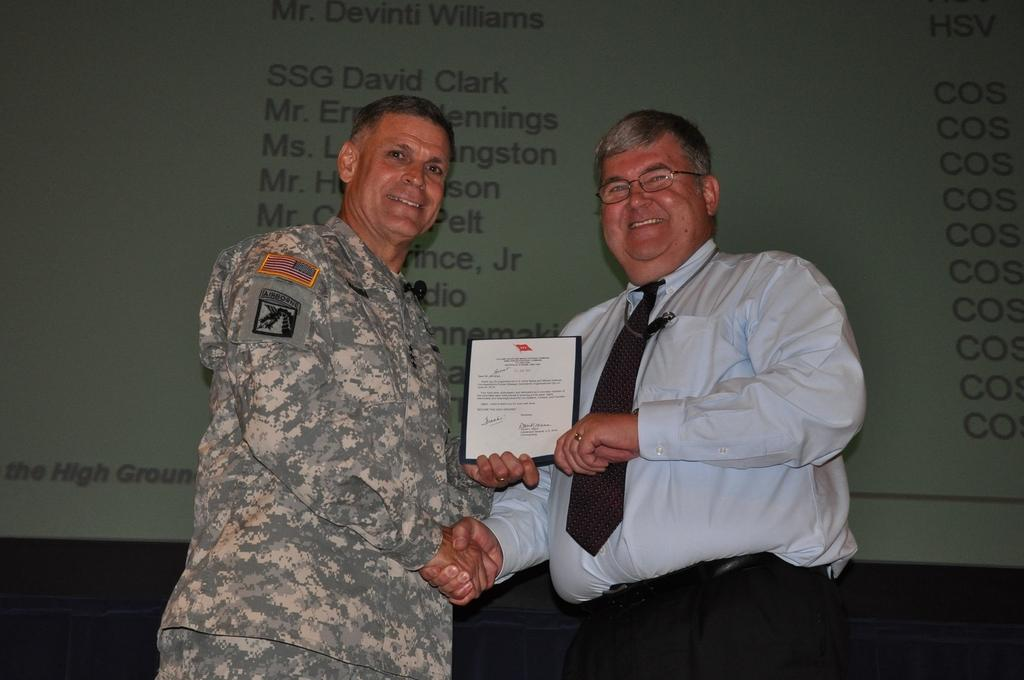How many people are in the image? There are two men in the image. Where are the men located in the image? The men are in the center of the image. What are the men holding in the image? The men are holding a book. What can be seen in the background of the image? There is a projector screen in the background of the image. What type of plants can be seen growing on the spot in the image? There are no plants or spots visible in the image; it features two men holding a book and a projector screen in the background. 